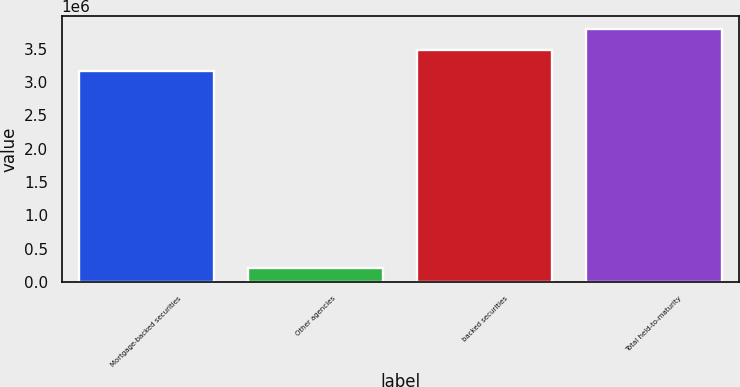Convert chart to OTSL. <chart><loc_0><loc_0><loc_500><loc_500><bar_chart><fcel>Mortgage-backed securities<fcel>Other agencies<fcel>backed securities<fcel>Total held-to-maturity<nl><fcel>3.16446e+06<fcel>210664<fcel>3.48166e+06<fcel>3.79887e+06<nl></chart> 